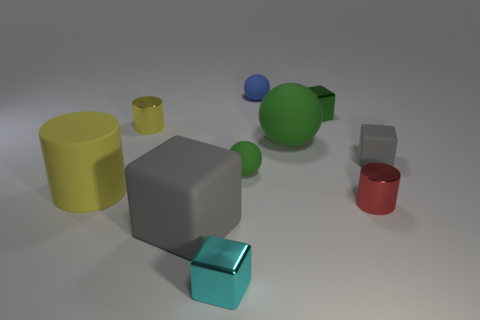There is a cube that is the same size as the matte cylinder; what is its color?
Ensure brevity in your answer.  Gray. There is a gray rubber object that is to the left of the blue matte ball; is its size the same as the small yellow cylinder?
Offer a very short reply. No. Is the color of the tiny rubber block the same as the large matte sphere?
Offer a terse response. No. What number of small green metallic spheres are there?
Keep it short and to the point. 0. What number of blocks are either cyan metal objects or green rubber things?
Offer a terse response. 1. There is a small metallic block that is behind the large yellow thing; how many shiny blocks are on the left side of it?
Offer a very short reply. 1. Is the material of the small cyan block the same as the blue thing?
Make the answer very short. No. What is the size of the matte object that is the same color as the large ball?
Provide a succinct answer. Small. Are there any tiny blue balls made of the same material as the tiny gray cube?
Your response must be concise. Yes. There is a small metallic cube behind the thing that is to the left of the yellow object behind the small gray matte object; what color is it?
Your answer should be compact. Green. 